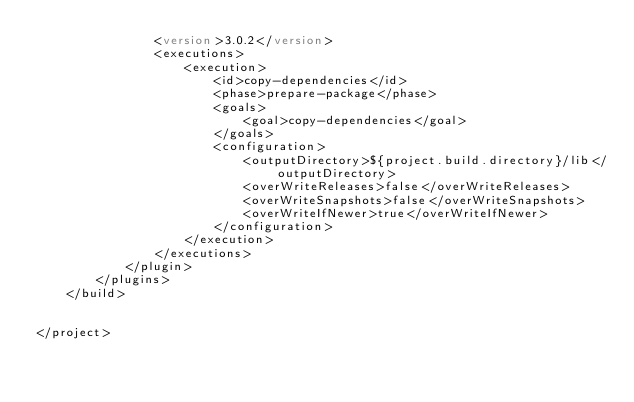Convert code to text. <code><loc_0><loc_0><loc_500><loc_500><_XML_>                <version>3.0.2</version>
                <executions>
                    <execution>
                        <id>copy-dependencies</id>
                        <phase>prepare-package</phase>
                        <goals>
                            <goal>copy-dependencies</goal>
                        </goals>
                        <configuration>
                            <outputDirectory>${project.build.directory}/lib</outputDirectory>
                            <overWriteReleases>false</overWriteReleases>
                            <overWriteSnapshots>false</overWriteSnapshots>
                            <overWriteIfNewer>true</overWriteIfNewer>
                        </configuration>
                    </execution>
                </executions>
            </plugin>
        </plugins>
    </build>


</project></code> 